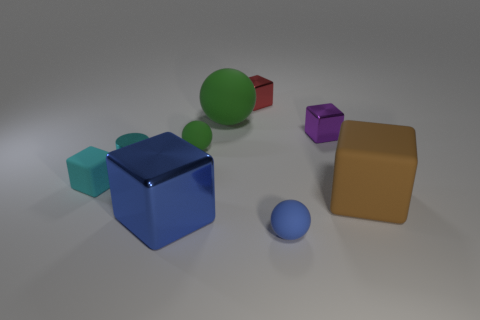Are there any cyan matte objects in front of the tiny blue object?
Provide a succinct answer. No. Are there an equal number of red things that are behind the red cube and big blue shiny blocks that are behind the brown rubber block?
Offer a terse response. Yes. Do the metallic object that is behind the large rubber ball and the green rubber ball that is behind the purple thing have the same size?
Make the answer very short. No. There is a blue thing that is to the right of the green thing to the right of the small ball that is behind the small blue object; what is its shape?
Provide a short and direct response. Sphere. Is there anything else that has the same material as the brown block?
Ensure brevity in your answer.  Yes. The blue metallic thing that is the same shape as the tiny purple metallic thing is what size?
Offer a terse response. Large. What is the color of the thing that is both in front of the brown rubber object and behind the blue sphere?
Ensure brevity in your answer.  Blue. Does the blue sphere have the same material as the tiny ball that is behind the blue metallic cube?
Keep it short and to the point. Yes. Are there fewer cyan cylinders in front of the cyan cylinder than tiny gray matte spheres?
Your answer should be very brief. No. How many other things are there of the same shape as the cyan rubber object?
Make the answer very short. 4. 